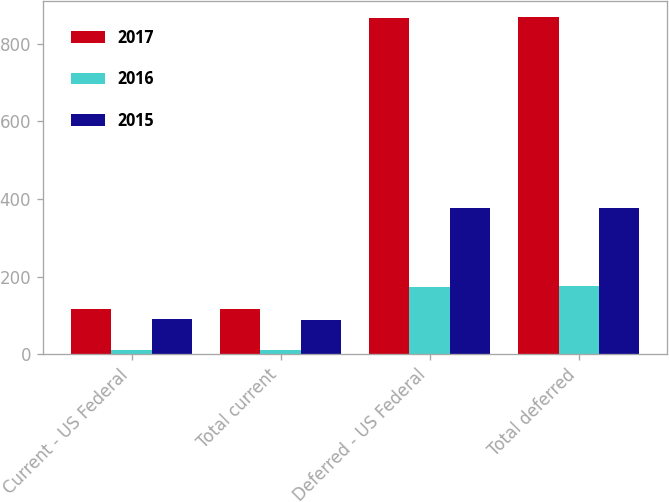<chart> <loc_0><loc_0><loc_500><loc_500><stacked_bar_chart><ecel><fcel>Current - US Federal<fcel>Total current<fcel>Deferred - US Federal<fcel>Total deferred<nl><fcel>2017<fcel>116<fcel>117<fcel>866<fcel>868<nl><fcel>2016<fcel>10<fcel>10<fcel>173<fcel>176<nl><fcel>2015<fcel>91<fcel>88<fcel>377<fcel>377<nl></chart> 